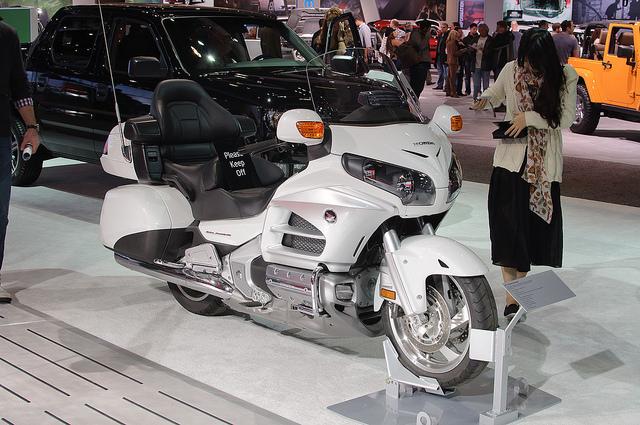Is the woman planning to buy a motorbike?
Be succinct. Yes. Is the lady wearing panties?
Give a very brief answer. Yes. How many yellow trucks are there?
Give a very brief answer. 1. 